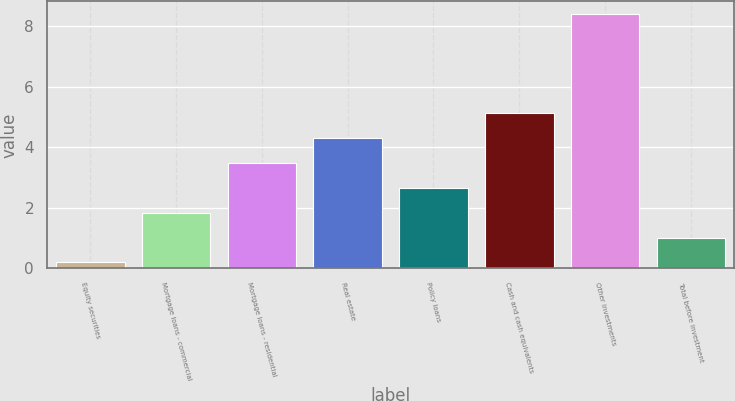<chart> <loc_0><loc_0><loc_500><loc_500><bar_chart><fcel>Equity securities<fcel>Mortgage loans - commercial<fcel>Mortgage loans - residential<fcel>Real estate<fcel>Policy loans<fcel>Cash and cash equivalents<fcel>Other investments<fcel>Total before investment<nl><fcel>0.2<fcel>1.84<fcel>3.48<fcel>4.3<fcel>2.66<fcel>5.12<fcel>8.4<fcel>1.02<nl></chart> 